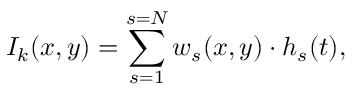<formula> <loc_0><loc_0><loc_500><loc_500>I _ { k } ( x , y ) = \sum _ { s = 1 } ^ { s = N } w _ { s } ( x , y ) \cdot h _ { s } ( t ) ,</formula> 